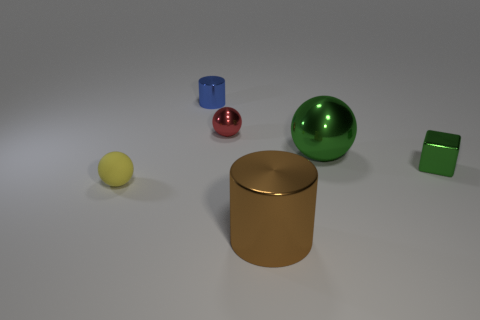Add 3 tiny green things. How many objects exist? 9 Subtract all cylinders. How many objects are left? 4 Add 1 brown shiny things. How many brown shiny things exist? 2 Subtract 1 green blocks. How many objects are left? 5 Subtract all yellow objects. Subtract all tiny red metal objects. How many objects are left? 4 Add 5 green balls. How many green balls are left? 6 